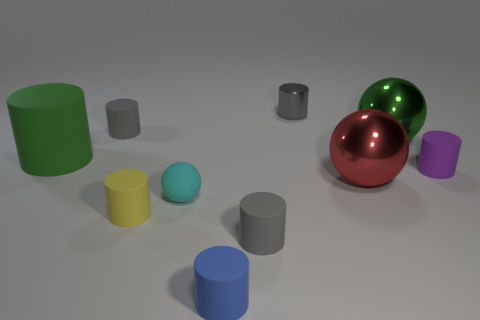There is a large green metal thing; does it have the same shape as the small gray matte thing behind the big green sphere?
Your answer should be compact. No. Is there another small ball made of the same material as the cyan sphere?
Offer a terse response. No. Is there any other thing that is made of the same material as the tiny yellow thing?
Your answer should be compact. Yes. There is a big thing left of the small gray matte thing in front of the yellow cylinder; what is its material?
Provide a succinct answer. Rubber. What is the size of the red shiny thing that is on the right side of the gray matte thing that is to the left of the gray cylinder that is in front of the tiny purple matte cylinder?
Provide a short and direct response. Large. How many other things are there of the same shape as the small metal object?
Keep it short and to the point. 6. Is the color of the tiny cylinder right of the green shiny thing the same as the small matte sphere that is behind the tiny blue rubber object?
Ensure brevity in your answer.  No. What is the color of the metallic object that is the same size as the cyan sphere?
Your answer should be very brief. Gray. Are there any small cylinders of the same color as the small matte ball?
Your answer should be very brief. No. Is the size of the cylinder that is to the right of the red metallic sphere the same as the cyan object?
Your answer should be very brief. Yes. 